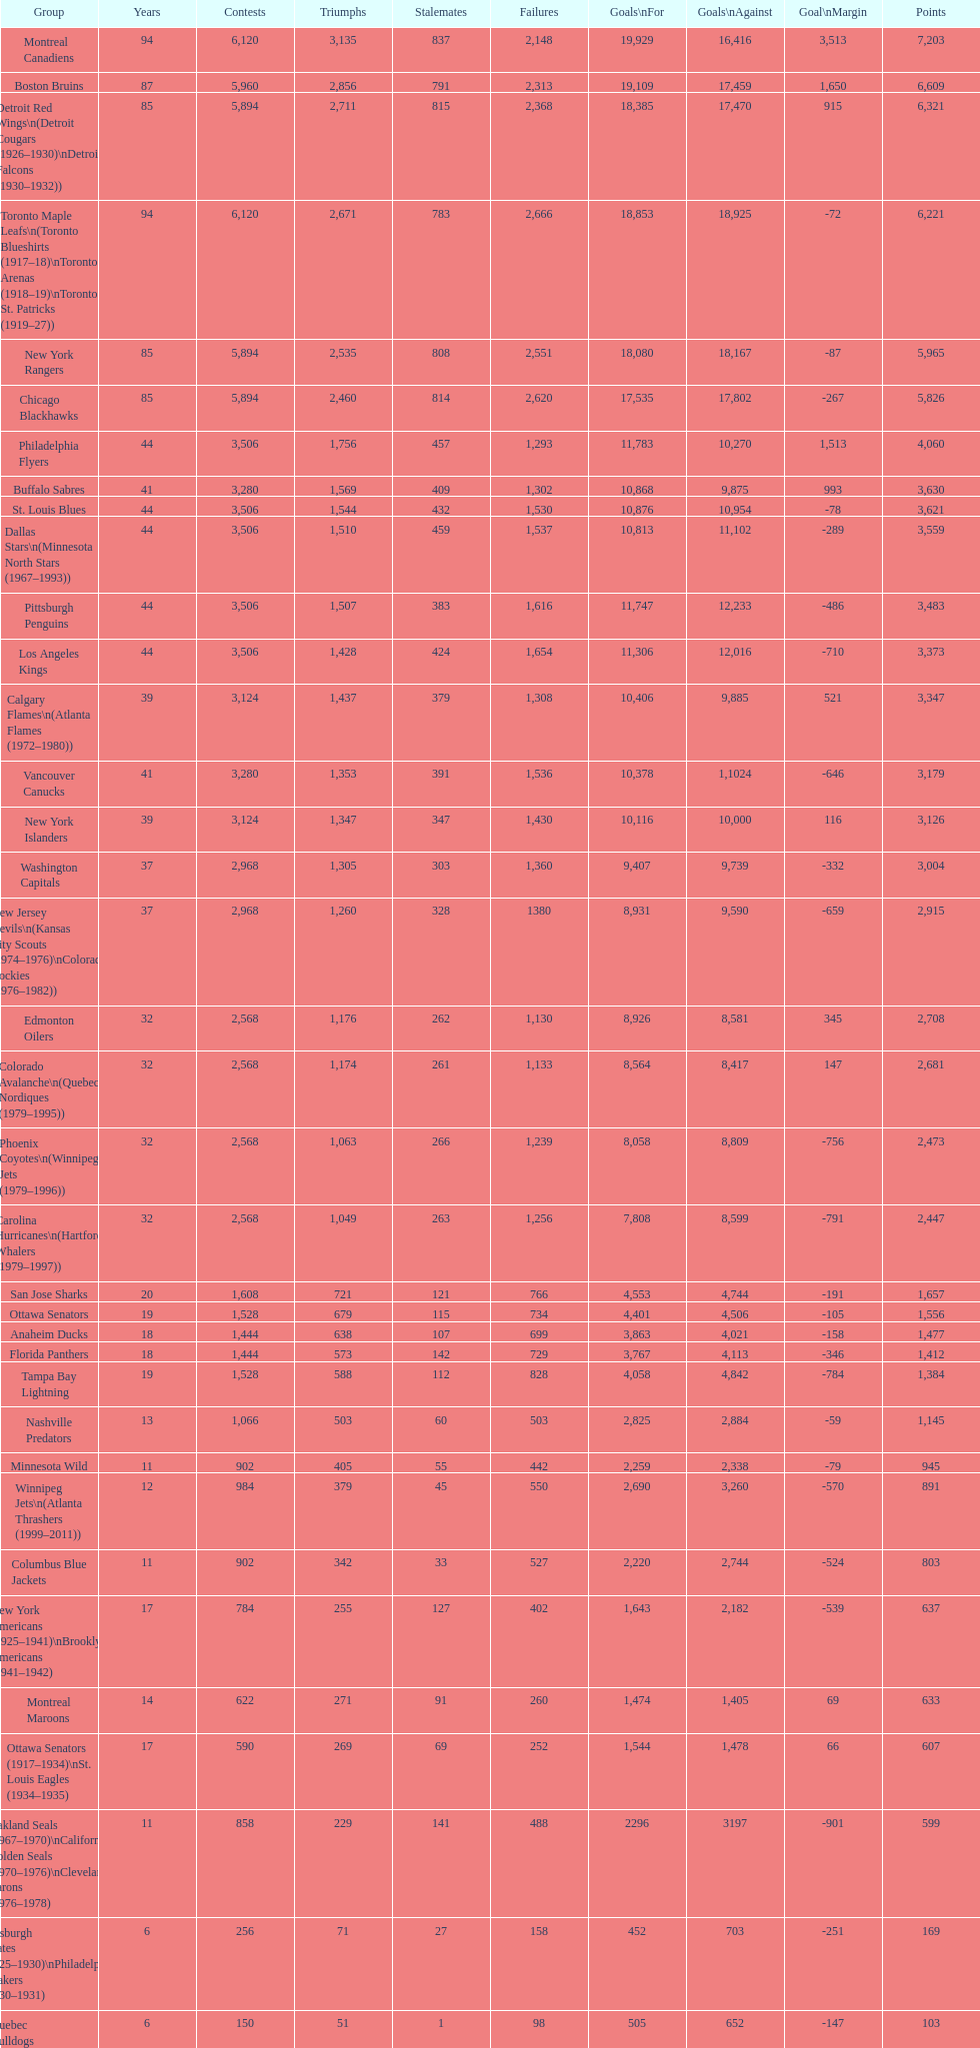Which team played the same amount of seasons as the canadiens? Toronto Maple Leafs. 